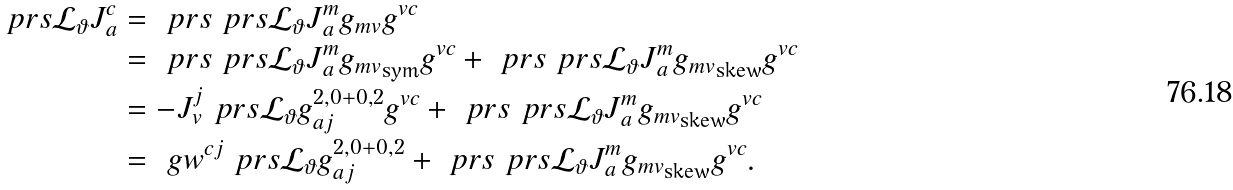<formula> <loc_0><loc_0><loc_500><loc_500>\ p r s { \mathcal { L } _ { \vartheta } J } _ { a } ^ { c } & = \ p r s { \ p r s { \mathcal { L } _ { \vartheta } J } ^ { m } _ { a } g _ { m v } } g ^ { v c } \\ & = \ p r s { \ p r s { \mathcal { L } _ { \vartheta } J } ^ { m } _ { a } g _ { m v } } _ { \text {sym} } g ^ { v c } + \ p r s { \ p r s { \mathcal { L } _ { \vartheta } J } ^ { m } _ { a } g _ { m v } } _ { \text {skew} } g ^ { v c } \\ & = - J _ { v } ^ { j } \ p r s { \mathcal { L } _ { \vartheta } g } _ { a j } ^ { 2 , 0 + 0 , 2 } g ^ { v c } + \ p r s { \ p r s { \mathcal { L } _ { \vartheta } J } ^ { m } _ { a } g _ { m v } } _ { \text {skew} } g ^ { v c } \\ & = \ g w ^ { c j } \ p r s { \mathcal { L } _ { \vartheta } g } _ { a j } ^ { 2 , 0 + 0 , 2 } + \ p r s { \ p r s { \mathcal { L } _ { \vartheta } J } ^ { m } _ { a } g _ { m v } } _ { \text {skew} } g ^ { v c } .</formula> 